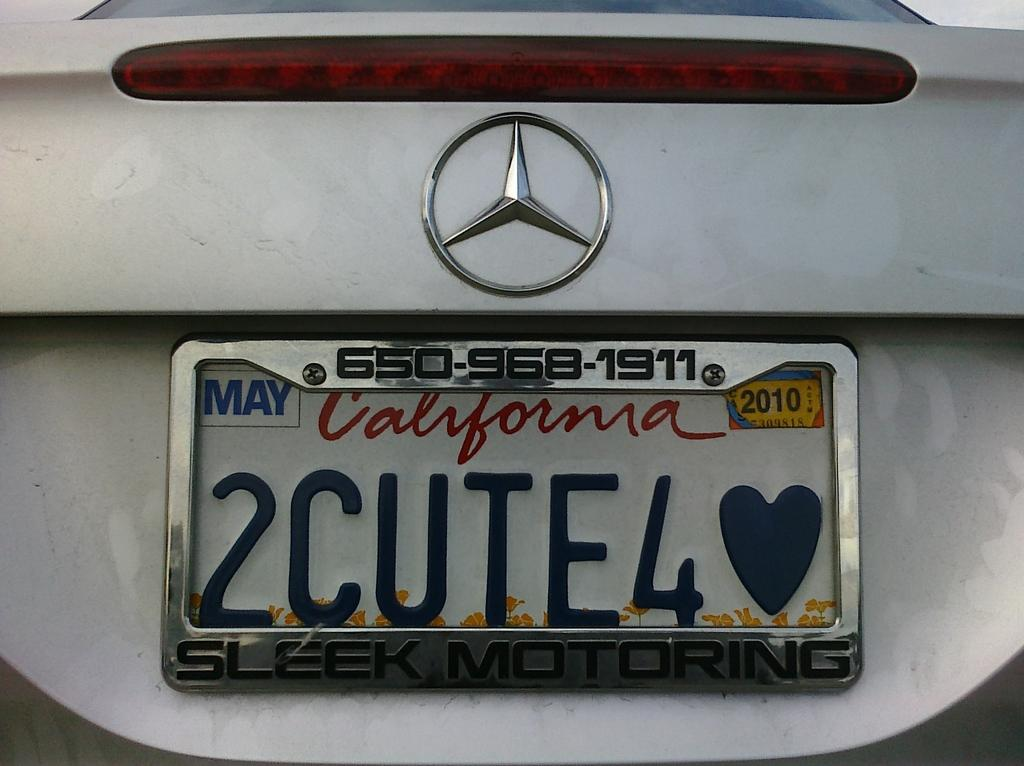<image>
Offer a succinct explanation of the picture presented. White California license plate which says 2CUTE4 on it. 